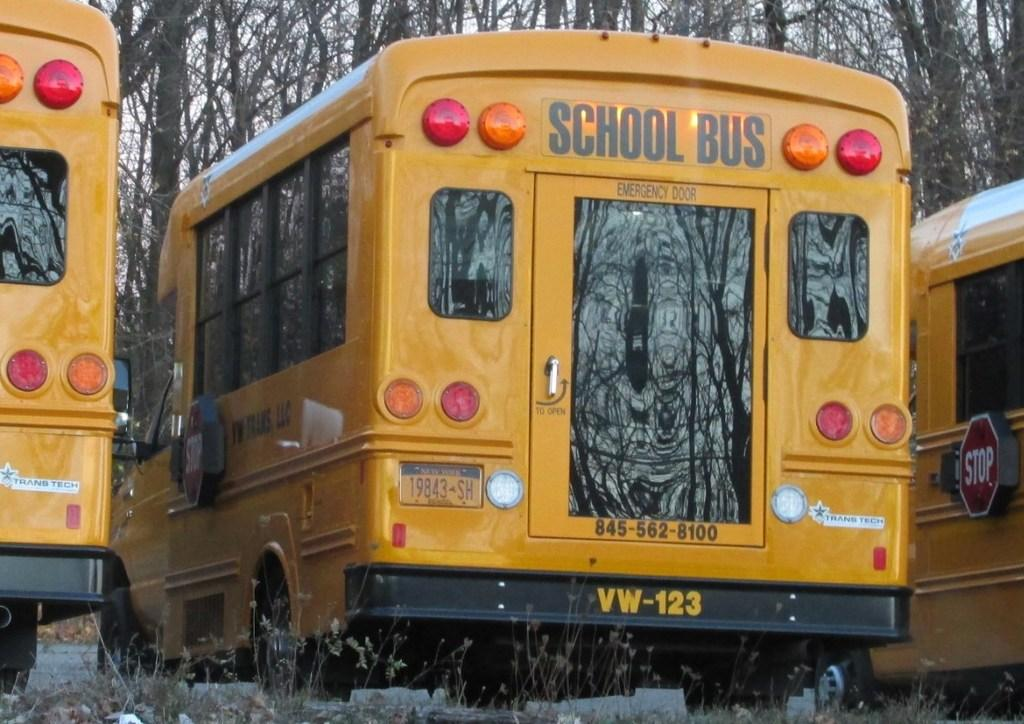What type of vehicles are on the ground in the image? There are buses on the ground in the image. What information is displayed on the buses? The buses have signboards on them. What type of vegetation can be seen in the image? There are plants visible in the image. What can be seen in the background of the image? There are trees in the background of the image. How many tigers are visible in the image? There are no tigers present in the image. What year is depicted on the buses in the image? The provided facts do not mention any specific year or date on the buses. 